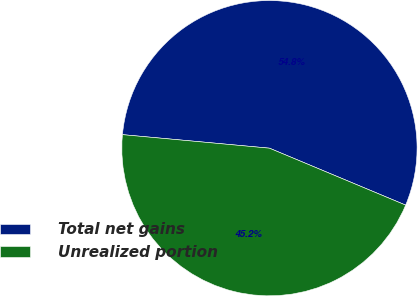Convert chart to OTSL. <chart><loc_0><loc_0><loc_500><loc_500><pie_chart><fcel>Total net gains<fcel>Unrealized portion<nl><fcel>54.84%<fcel>45.16%<nl></chart> 